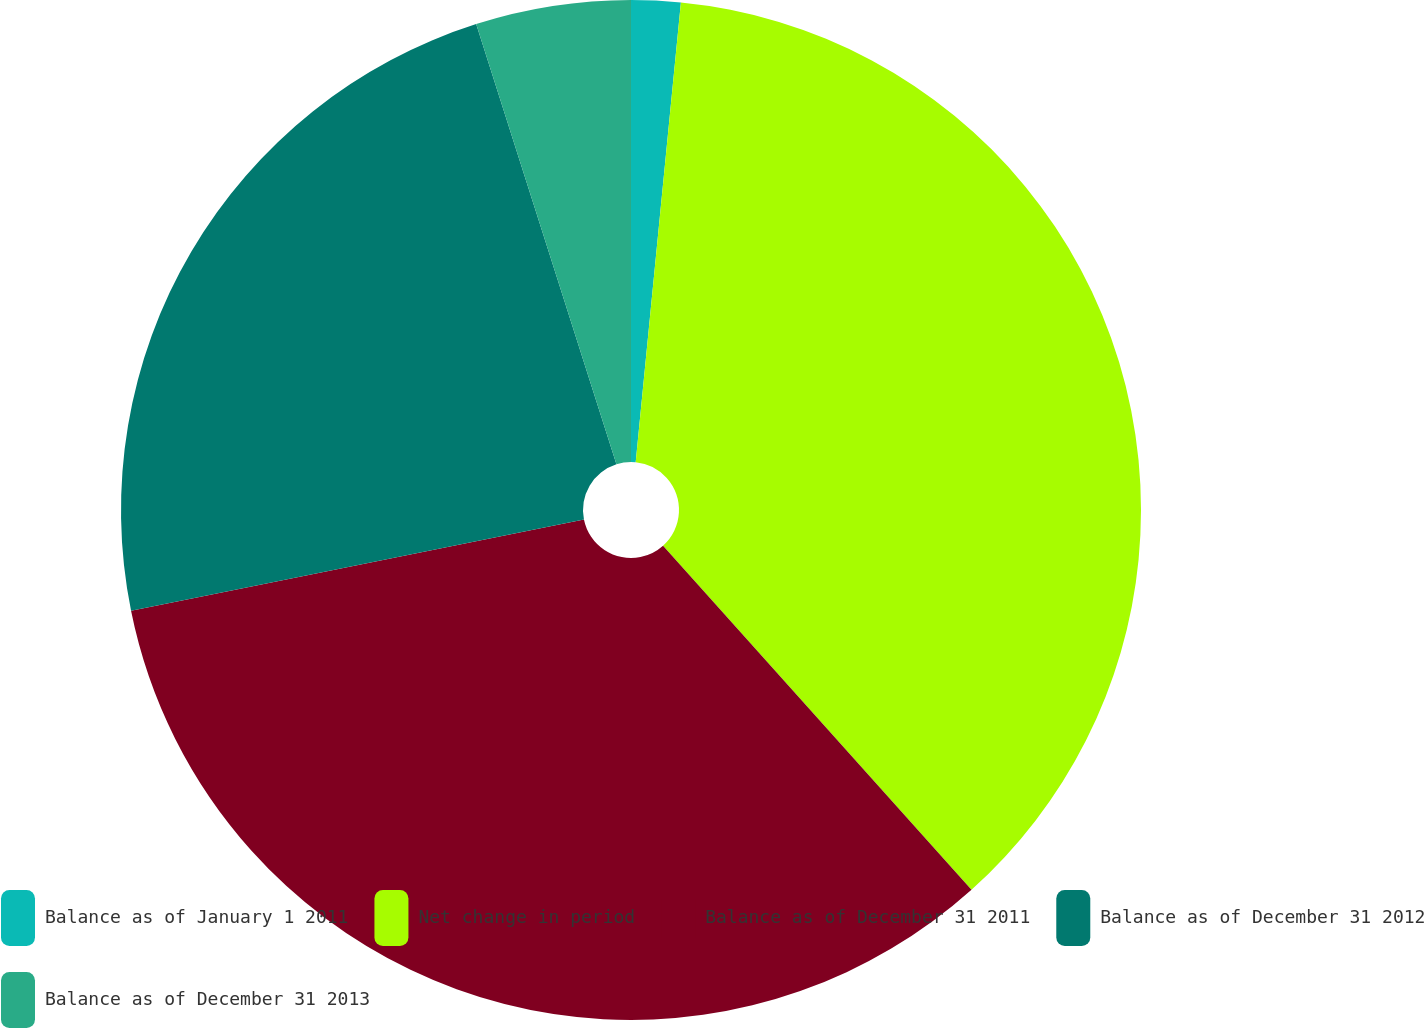Convert chart. <chart><loc_0><loc_0><loc_500><loc_500><pie_chart><fcel>Balance as of January 1 2011<fcel>Net change in period<fcel>Balance as of December 31 2011<fcel>Balance as of December 31 2012<fcel>Balance as of December 31 2013<nl><fcel>1.56%<fcel>36.81%<fcel>33.47%<fcel>23.26%<fcel>4.91%<nl></chart> 